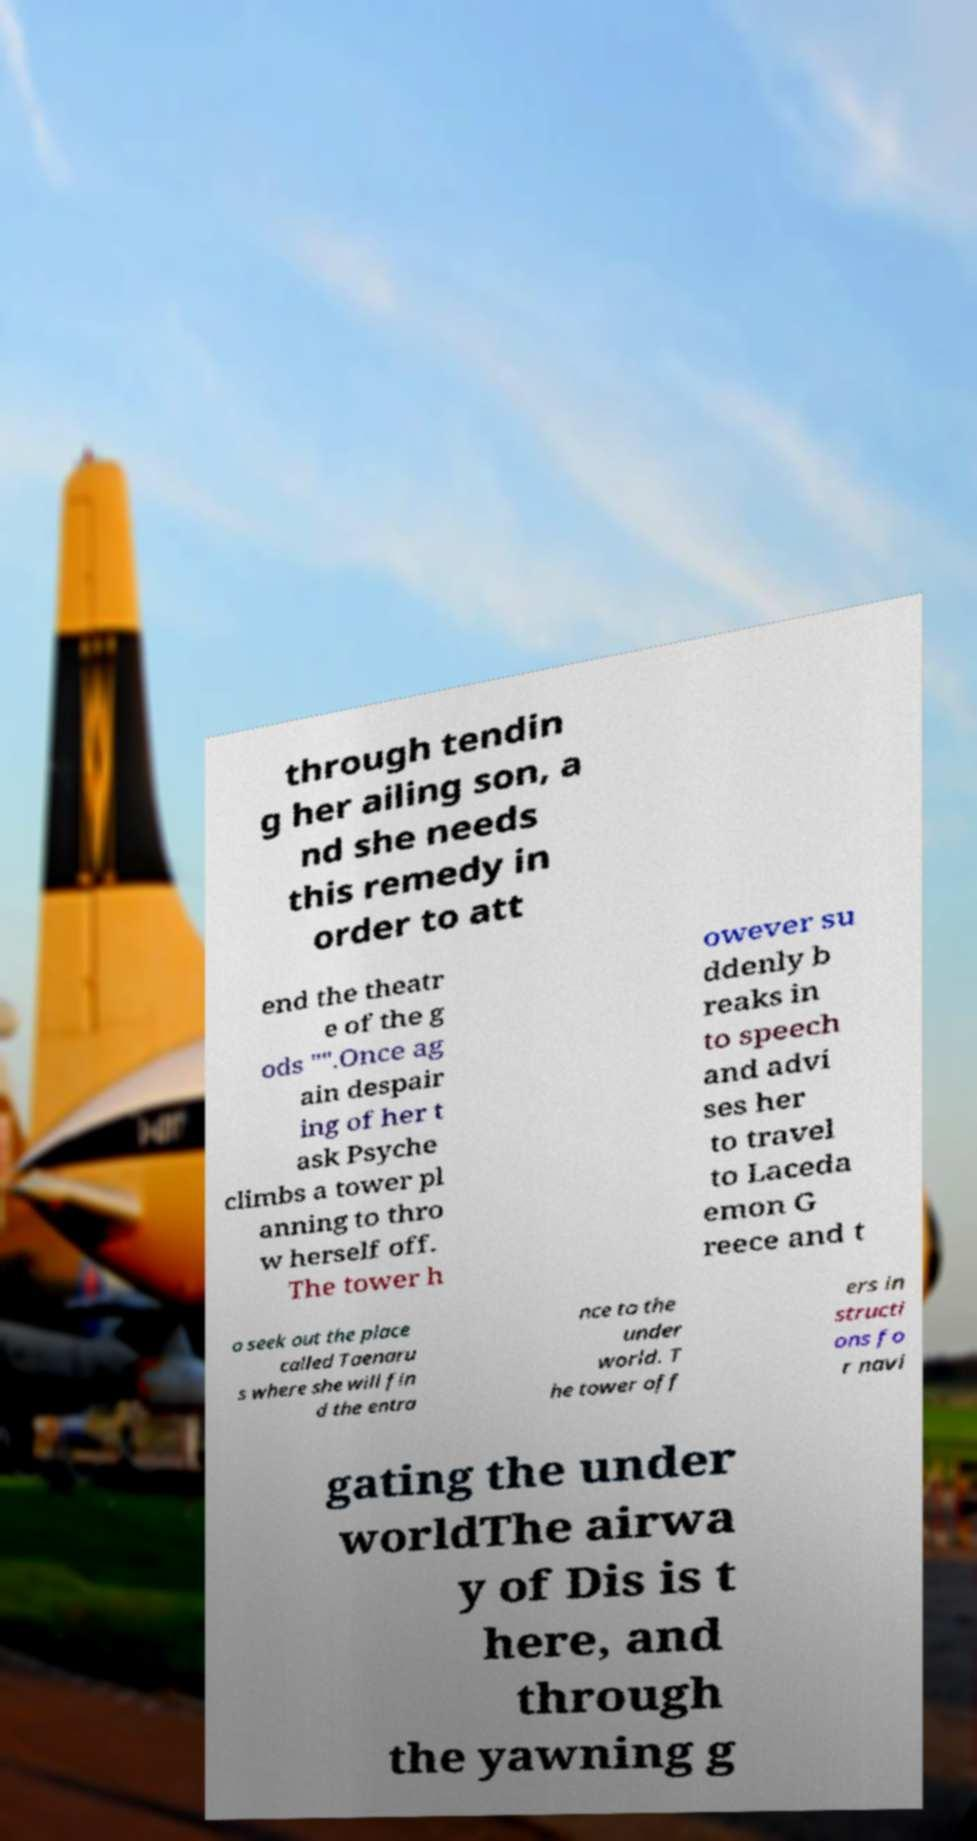There's text embedded in this image that I need extracted. Can you transcribe it verbatim? through tendin g her ailing son, a nd she needs this remedy in order to att end the theatr e of the g ods "".Once ag ain despair ing of her t ask Psyche climbs a tower pl anning to thro w herself off. The tower h owever su ddenly b reaks in to speech and advi ses her to travel to Laceda emon G reece and t o seek out the place called Taenaru s where she will fin d the entra nce to the under world. T he tower off ers in structi ons fo r navi gating the under worldThe airwa y of Dis is t here, and through the yawning g 